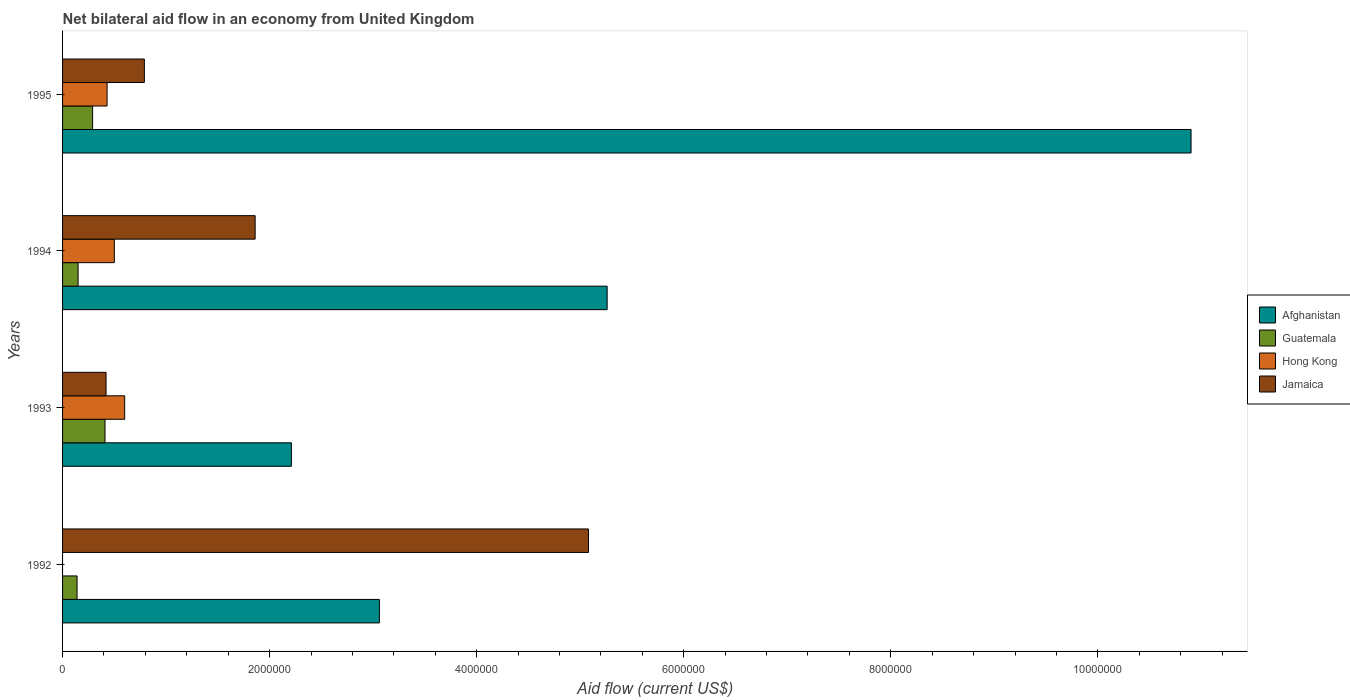What is the net bilateral aid flow in Jamaica in 1992?
Offer a terse response. 5.08e+06. What is the total net bilateral aid flow in Hong Kong in the graph?
Your answer should be very brief. 1.53e+06. What is the difference between the net bilateral aid flow in Afghanistan in 1994 and that in 1995?
Give a very brief answer. -5.64e+06. What is the difference between the net bilateral aid flow in Jamaica in 1993 and the net bilateral aid flow in Afghanistan in 1995?
Offer a very short reply. -1.05e+07. What is the average net bilateral aid flow in Afghanistan per year?
Provide a short and direct response. 5.36e+06. In the year 1992, what is the difference between the net bilateral aid flow in Jamaica and net bilateral aid flow in Afghanistan?
Your answer should be compact. 2.02e+06. What is the ratio of the net bilateral aid flow in Afghanistan in 1993 to that in 1994?
Your answer should be compact. 0.42. Is the net bilateral aid flow in Hong Kong in 1993 less than that in 1995?
Offer a terse response. No. What is the difference between the highest and the second highest net bilateral aid flow in Jamaica?
Offer a terse response. 3.22e+06. What is the difference between the highest and the lowest net bilateral aid flow in Afghanistan?
Offer a terse response. 8.69e+06. In how many years, is the net bilateral aid flow in Hong Kong greater than the average net bilateral aid flow in Hong Kong taken over all years?
Provide a succinct answer. 3. Is the sum of the net bilateral aid flow in Jamaica in 1993 and 1994 greater than the maximum net bilateral aid flow in Afghanistan across all years?
Offer a very short reply. No. Is it the case that in every year, the sum of the net bilateral aid flow in Hong Kong and net bilateral aid flow in Jamaica is greater than the net bilateral aid flow in Guatemala?
Give a very brief answer. Yes. What is the difference between two consecutive major ticks on the X-axis?
Offer a terse response. 2.00e+06. Does the graph contain grids?
Give a very brief answer. No. Where does the legend appear in the graph?
Provide a succinct answer. Center right. What is the title of the graph?
Offer a terse response. Net bilateral aid flow in an economy from United Kingdom. Does "Albania" appear as one of the legend labels in the graph?
Keep it short and to the point. No. What is the label or title of the X-axis?
Provide a succinct answer. Aid flow (current US$). What is the Aid flow (current US$) of Afghanistan in 1992?
Make the answer very short. 3.06e+06. What is the Aid flow (current US$) of Guatemala in 1992?
Your response must be concise. 1.40e+05. What is the Aid flow (current US$) in Hong Kong in 1992?
Offer a terse response. 0. What is the Aid flow (current US$) of Jamaica in 1992?
Offer a terse response. 5.08e+06. What is the Aid flow (current US$) of Afghanistan in 1993?
Provide a short and direct response. 2.21e+06. What is the Aid flow (current US$) of Jamaica in 1993?
Provide a succinct answer. 4.20e+05. What is the Aid flow (current US$) in Afghanistan in 1994?
Give a very brief answer. 5.26e+06. What is the Aid flow (current US$) in Hong Kong in 1994?
Your answer should be compact. 5.00e+05. What is the Aid flow (current US$) of Jamaica in 1994?
Give a very brief answer. 1.86e+06. What is the Aid flow (current US$) of Afghanistan in 1995?
Offer a terse response. 1.09e+07. What is the Aid flow (current US$) in Jamaica in 1995?
Ensure brevity in your answer.  7.90e+05. Across all years, what is the maximum Aid flow (current US$) in Afghanistan?
Your answer should be very brief. 1.09e+07. Across all years, what is the maximum Aid flow (current US$) in Guatemala?
Ensure brevity in your answer.  4.10e+05. Across all years, what is the maximum Aid flow (current US$) of Jamaica?
Provide a succinct answer. 5.08e+06. Across all years, what is the minimum Aid flow (current US$) of Afghanistan?
Make the answer very short. 2.21e+06. Across all years, what is the minimum Aid flow (current US$) of Hong Kong?
Offer a very short reply. 0. Across all years, what is the minimum Aid flow (current US$) of Jamaica?
Your response must be concise. 4.20e+05. What is the total Aid flow (current US$) of Afghanistan in the graph?
Offer a very short reply. 2.14e+07. What is the total Aid flow (current US$) in Guatemala in the graph?
Give a very brief answer. 9.90e+05. What is the total Aid flow (current US$) in Hong Kong in the graph?
Your answer should be compact. 1.53e+06. What is the total Aid flow (current US$) in Jamaica in the graph?
Make the answer very short. 8.15e+06. What is the difference between the Aid flow (current US$) in Afghanistan in 1992 and that in 1993?
Provide a short and direct response. 8.50e+05. What is the difference between the Aid flow (current US$) in Jamaica in 1992 and that in 1993?
Provide a short and direct response. 4.66e+06. What is the difference between the Aid flow (current US$) in Afghanistan in 1992 and that in 1994?
Provide a short and direct response. -2.20e+06. What is the difference between the Aid flow (current US$) of Guatemala in 1992 and that in 1994?
Provide a short and direct response. -10000. What is the difference between the Aid flow (current US$) in Jamaica in 1992 and that in 1994?
Offer a very short reply. 3.22e+06. What is the difference between the Aid flow (current US$) in Afghanistan in 1992 and that in 1995?
Offer a very short reply. -7.84e+06. What is the difference between the Aid flow (current US$) in Guatemala in 1992 and that in 1995?
Keep it short and to the point. -1.50e+05. What is the difference between the Aid flow (current US$) in Jamaica in 1992 and that in 1995?
Provide a short and direct response. 4.29e+06. What is the difference between the Aid flow (current US$) of Afghanistan in 1993 and that in 1994?
Your answer should be very brief. -3.05e+06. What is the difference between the Aid flow (current US$) in Jamaica in 1993 and that in 1994?
Keep it short and to the point. -1.44e+06. What is the difference between the Aid flow (current US$) of Afghanistan in 1993 and that in 1995?
Provide a succinct answer. -8.69e+06. What is the difference between the Aid flow (current US$) in Guatemala in 1993 and that in 1995?
Provide a succinct answer. 1.20e+05. What is the difference between the Aid flow (current US$) of Jamaica in 1993 and that in 1995?
Ensure brevity in your answer.  -3.70e+05. What is the difference between the Aid flow (current US$) in Afghanistan in 1994 and that in 1995?
Give a very brief answer. -5.64e+06. What is the difference between the Aid flow (current US$) in Guatemala in 1994 and that in 1995?
Your answer should be very brief. -1.40e+05. What is the difference between the Aid flow (current US$) in Jamaica in 1994 and that in 1995?
Offer a terse response. 1.07e+06. What is the difference between the Aid flow (current US$) in Afghanistan in 1992 and the Aid flow (current US$) in Guatemala in 1993?
Your answer should be compact. 2.65e+06. What is the difference between the Aid flow (current US$) of Afghanistan in 1992 and the Aid flow (current US$) of Hong Kong in 1993?
Ensure brevity in your answer.  2.46e+06. What is the difference between the Aid flow (current US$) in Afghanistan in 1992 and the Aid flow (current US$) in Jamaica in 1993?
Offer a very short reply. 2.64e+06. What is the difference between the Aid flow (current US$) in Guatemala in 1992 and the Aid flow (current US$) in Hong Kong in 1993?
Keep it short and to the point. -4.60e+05. What is the difference between the Aid flow (current US$) of Guatemala in 1992 and the Aid flow (current US$) of Jamaica in 1993?
Offer a terse response. -2.80e+05. What is the difference between the Aid flow (current US$) in Afghanistan in 1992 and the Aid flow (current US$) in Guatemala in 1994?
Ensure brevity in your answer.  2.91e+06. What is the difference between the Aid flow (current US$) in Afghanistan in 1992 and the Aid flow (current US$) in Hong Kong in 1994?
Offer a very short reply. 2.56e+06. What is the difference between the Aid flow (current US$) in Afghanistan in 1992 and the Aid flow (current US$) in Jamaica in 1994?
Provide a succinct answer. 1.20e+06. What is the difference between the Aid flow (current US$) of Guatemala in 1992 and the Aid flow (current US$) of Hong Kong in 1994?
Keep it short and to the point. -3.60e+05. What is the difference between the Aid flow (current US$) in Guatemala in 1992 and the Aid flow (current US$) in Jamaica in 1994?
Your answer should be compact. -1.72e+06. What is the difference between the Aid flow (current US$) in Afghanistan in 1992 and the Aid flow (current US$) in Guatemala in 1995?
Ensure brevity in your answer.  2.77e+06. What is the difference between the Aid flow (current US$) of Afghanistan in 1992 and the Aid flow (current US$) of Hong Kong in 1995?
Keep it short and to the point. 2.63e+06. What is the difference between the Aid flow (current US$) of Afghanistan in 1992 and the Aid flow (current US$) of Jamaica in 1995?
Your response must be concise. 2.27e+06. What is the difference between the Aid flow (current US$) in Guatemala in 1992 and the Aid flow (current US$) in Hong Kong in 1995?
Provide a succinct answer. -2.90e+05. What is the difference between the Aid flow (current US$) of Guatemala in 1992 and the Aid flow (current US$) of Jamaica in 1995?
Ensure brevity in your answer.  -6.50e+05. What is the difference between the Aid flow (current US$) of Afghanistan in 1993 and the Aid flow (current US$) of Guatemala in 1994?
Make the answer very short. 2.06e+06. What is the difference between the Aid flow (current US$) of Afghanistan in 1993 and the Aid flow (current US$) of Hong Kong in 1994?
Give a very brief answer. 1.71e+06. What is the difference between the Aid flow (current US$) in Afghanistan in 1993 and the Aid flow (current US$) in Jamaica in 1994?
Ensure brevity in your answer.  3.50e+05. What is the difference between the Aid flow (current US$) in Guatemala in 1993 and the Aid flow (current US$) in Hong Kong in 1994?
Keep it short and to the point. -9.00e+04. What is the difference between the Aid flow (current US$) in Guatemala in 1993 and the Aid flow (current US$) in Jamaica in 1994?
Keep it short and to the point. -1.45e+06. What is the difference between the Aid flow (current US$) in Hong Kong in 1993 and the Aid flow (current US$) in Jamaica in 1994?
Your response must be concise. -1.26e+06. What is the difference between the Aid flow (current US$) of Afghanistan in 1993 and the Aid flow (current US$) of Guatemala in 1995?
Your answer should be very brief. 1.92e+06. What is the difference between the Aid flow (current US$) in Afghanistan in 1993 and the Aid flow (current US$) in Hong Kong in 1995?
Your response must be concise. 1.78e+06. What is the difference between the Aid flow (current US$) in Afghanistan in 1993 and the Aid flow (current US$) in Jamaica in 1995?
Provide a succinct answer. 1.42e+06. What is the difference between the Aid flow (current US$) of Guatemala in 1993 and the Aid flow (current US$) of Hong Kong in 1995?
Offer a terse response. -2.00e+04. What is the difference between the Aid flow (current US$) in Guatemala in 1993 and the Aid flow (current US$) in Jamaica in 1995?
Your response must be concise. -3.80e+05. What is the difference between the Aid flow (current US$) in Hong Kong in 1993 and the Aid flow (current US$) in Jamaica in 1995?
Ensure brevity in your answer.  -1.90e+05. What is the difference between the Aid flow (current US$) of Afghanistan in 1994 and the Aid flow (current US$) of Guatemala in 1995?
Ensure brevity in your answer.  4.97e+06. What is the difference between the Aid flow (current US$) in Afghanistan in 1994 and the Aid flow (current US$) in Hong Kong in 1995?
Your answer should be compact. 4.83e+06. What is the difference between the Aid flow (current US$) in Afghanistan in 1994 and the Aid flow (current US$) in Jamaica in 1995?
Offer a very short reply. 4.47e+06. What is the difference between the Aid flow (current US$) in Guatemala in 1994 and the Aid flow (current US$) in Hong Kong in 1995?
Make the answer very short. -2.80e+05. What is the difference between the Aid flow (current US$) in Guatemala in 1994 and the Aid flow (current US$) in Jamaica in 1995?
Give a very brief answer. -6.40e+05. What is the difference between the Aid flow (current US$) of Hong Kong in 1994 and the Aid flow (current US$) of Jamaica in 1995?
Your answer should be compact. -2.90e+05. What is the average Aid flow (current US$) in Afghanistan per year?
Your response must be concise. 5.36e+06. What is the average Aid flow (current US$) of Guatemala per year?
Make the answer very short. 2.48e+05. What is the average Aid flow (current US$) of Hong Kong per year?
Offer a very short reply. 3.82e+05. What is the average Aid flow (current US$) in Jamaica per year?
Ensure brevity in your answer.  2.04e+06. In the year 1992, what is the difference between the Aid flow (current US$) in Afghanistan and Aid flow (current US$) in Guatemala?
Your answer should be compact. 2.92e+06. In the year 1992, what is the difference between the Aid flow (current US$) of Afghanistan and Aid flow (current US$) of Jamaica?
Make the answer very short. -2.02e+06. In the year 1992, what is the difference between the Aid flow (current US$) of Guatemala and Aid flow (current US$) of Jamaica?
Your answer should be very brief. -4.94e+06. In the year 1993, what is the difference between the Aid flow (current US$) of Afghanistan and Aid flow (current US$) of Guatemala?
Your answer should be very brief. 1.80e+06. In the year 1993, what is the difference between the Aid flow (current US$) of Afghanistan and Aid flow (current US$) of Hong Kong?
Make the answer very short. 1.61e+06. In the year 1993, what is the difference between the Aid flow (current US$) in Afghanistan and Aid flow (current US$) in Jamaica?
Offer a terse response. 1.79e+06. In the year 1993, what is the difference between the Aid flow (current US$) of Guatemala and Aid flow (current US$) of Jamaica?
Your answer should be compact. -10000. In the year 1993, what is the difference between the Aid flow (current US$) in Hong Kong and Aid flow (current US$) in Jamaica?
Provide a short and direct response. 1.80e+05. In the year 1994, what is the difference between the Aid flow (current US$) in Afghanistan and Aid flow (current US$) in Guatemala?
Your response must be concise. 5.11e+06. In the year 1994, what is the difference between the Aid flow (current US$) of Afghanistan and Aid flow (current US$) of Hong Kong?
Your answer should be compact. 4.76e+06. In the year 1994, what is the difference between the Aid flow (current US$) of Afghanistan and Aid flow (current US$) of Jamaica?
Make the answer very short. 3.40e+06. In the year 1994, what is the difference between the Aid flow (current US$) of Guatemala and Aid flow (current US$) of Hong Kong?
Give a very brief answer. -3.50e+05. In the year 1994, what is the difference between the Aid flow (current US$) of Guatemala and Aid flow (current US$) of Jamaica?
Your answer should be compact. -1.71e+06. In the year 1994, what is the difference between the Aid flow (current US$) of Hong Kong and Aid flow (current US$) of Jamaica?
Offer a terse response. -1.36e+06. In the year 1995, what is the difference between the Aid flow (current US$) in Afghanistan and Aid flow (current US$) in Guatemala?
Give a very brief answer. 1.06e+07. In the year 1995, what is the difference between the Aid flow (current US$) of Afghanistan and Aid flow (current US$) of Hong Kong?
Provide a succinct answer. 1.05e+07. In the year 1995, what is the difference between the Aid flow (current US$) of Afghanistan and Aid flow (current US$) of Jamaica?
Your answer should be compact. 1.01e+07. In the year 1995, what is the difference between the Aid flow (current US$) in Guatemala and Aid flow (current US$) in Jamaica?
Provide a succinct answer. -5.00e+05. In the year 1995, what is the difference between the Aid flow (current US$) in Hong Kong and Aid flow (current US$) in Jamaica?
Ensure brevity in your answer.  -3.60e+05. What is the ratio of the Aid flow (current US$) in Afghanistan in 1992 to that in 1993?
Keep it short and to the point. 1.38. What is the ratio of the Aid flow (current US$) in Guatemala in 1992 to that in 1993?
Give a very brief answer. 0.34. What is the ratio of the Aid flow (current US$) in Jamaica in 1992 to that in 1993?
Ensure brevity in your answer.  12.1. What is the ratio of the Aid flow (current US$) of Afghanistan in 1992 to that in 1994?
Provide a short and direct response. 0.58. What is the ratio of the Aid flow (current US$) of Guatemala in 1992 to that in 1994?
Keep it short and to the point. 0.93. What is the ratio of the Aid flow (current US$) of Jamaica in 1992 to that in 1994?
Keep it short and to the point. 2.73. What is the ratio of the Aid flow (current US$) of Afghanistan in 1992 to that in 1995?
Give a very brief answer. 0.28. What is the ratio of the Aid flow (current US$) of Guatemala in 1992 to that in 1995?
Make the answer very short. 0.48. What is the ratio of the Aid flow (current US$) of Jamaica in 1992 to that in 1995?
Offer a terse response. 6.43. What is the ratio of the Aid flow (current US$) in Afghanistan in 1993 to that in 1994?
Keep it short and to the point. 0.42. What is the ratio of the Aid flow (current US$) in Guatemala in 1993 to that in 1994?
Keep it short and to the point. 2.73. What is the ratio of the Aid flow (current US$) in Jamaica in 1993 to that in 1994?
Your answer should be compact. 0.23. What is the ratio of the Aid flow (current US$) in Afghanistan in 1993 to that in 1995?
Your answer should be compact. 0.2. What is the ratio of the Aid flow (current US$) in Guatemala in 1993 to that in 1995?
Keep it short and to the point. 1.41. What is the ratio of the Aid flow (current US$) of Hong Kong in 1993 to that in 1995?
Make the answer very short. 1.4. What is the ratio of the Aid flow (current US$) of Jamaica in 1993 to that in 1995?
Give a very brief answer. 0.53. What is the ratio of the Aid flow (current US$) of Afghanistan in 1994 to that in 1995?
Your answer should be compact. 0.48. What is the ratio of the Aid flow (current US$) of Guatemala in 1994 to that in 1995?
Give a very brief answer. 0.52. What is the ratio of the Aid flow (current US$) in Hong Kong in 1994 to that in 1995?
Offer a terse response. 1.16. What is the ratio of the Aid flow (current US$) of Jamaica in 1994 to that in 1995?
Your answer should be compact. 2.35. What is the difference between the highest and the second highest Aid flow (current US$) in Afghanistan?
Ensure brevity in your answer.  5.64e+06. What is the difference between the highest and the second highest Aid flow (current US$) in Jamaica?
Your response must be concise. 3.22e+06. What is the difference between the highest and the lowest Aid flow (current US$) of Afghanistan?
Provide a succinct answer. 8.69e+06. What is the difference between the highest and the lowest Aid flow (current US$) in Guatemala?
Offer a very short reply. 2.70e+05. What is the difference between the highest and the lowest Aid flow (current US$) of Hong Kong?
Ensure brevity in your answer.  6.00e+05. What is the difference between the highest and the lowest Aid flow (current US$) of Jamaica?
Your response must be concise. 4.66e+06. 